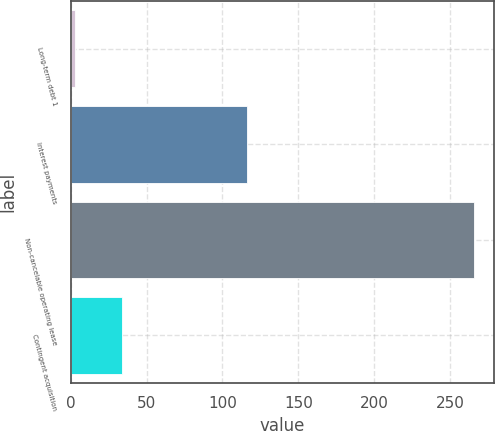<chart> <loc_0><loc_0><loc_500><loc_500><bar_chart><fcel>Long-term debt 1<fcel>Interest payments<fcel>Non-cancelable operating lease<fcel>Contingent acquisition<nl><fcel>2.8<fcel>116.1<fcel>265.2<fcel>34.2<nl></chart> 